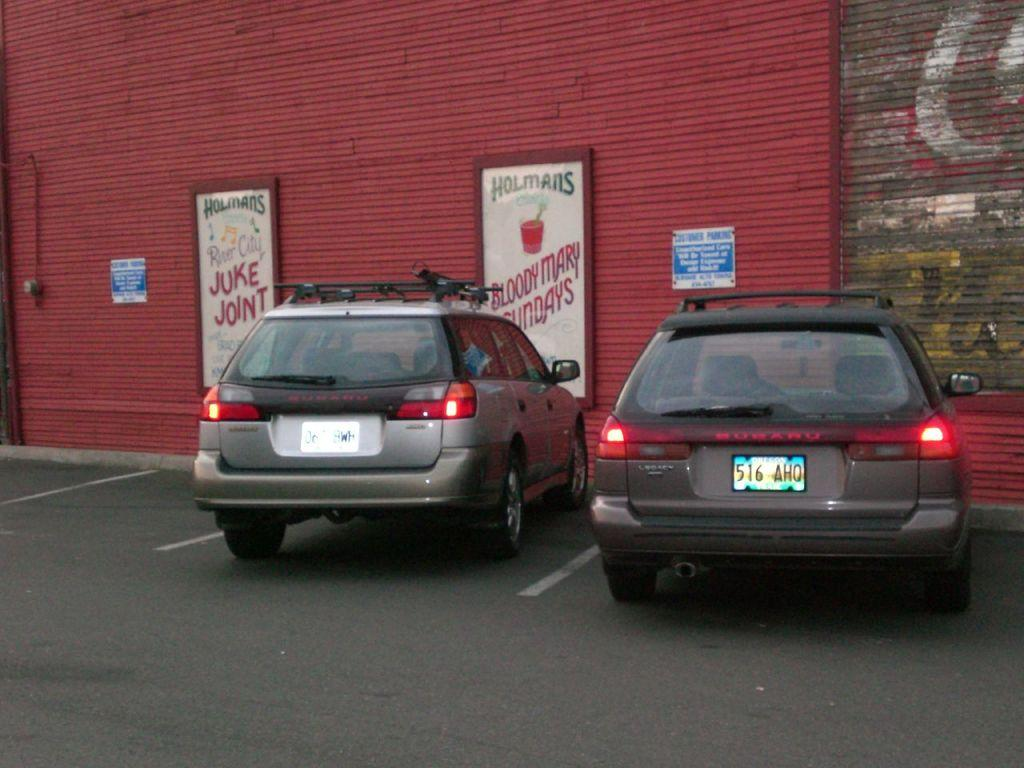How many cars can be seen in the image? There are two cars in the image. Where are the cars located? The cars are on the road. What can be seen in the background of the image? There is a wall in the background of the image. What is attached to the wall? There are boards on the wall. Can you see any wings on the cars in the image? No, there are no wings visible on the cars in the image. What type of brush is being used by the driver of the car? There is no brush present in the image, and the driver's actions are not visible. 